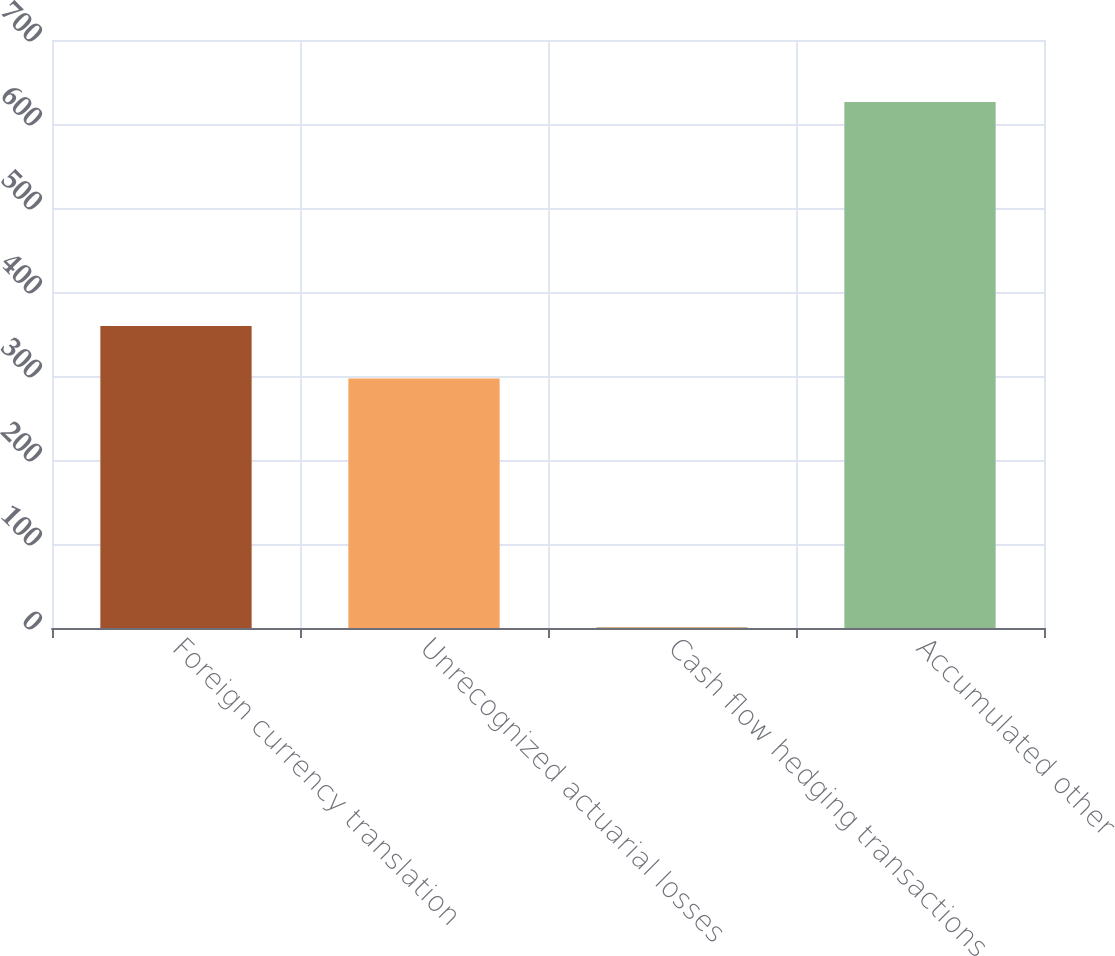<chart> <loc_0><loc_0><loc_500><loc_500><bar_chart><fcel>Foreign currency translation<fcel>Unrecognized actuarial losses<fcel>Cash flow hedging transactions<fcel>Accumulated other<nl><fcel>359.61<fcel>297.1<fcel>1.2<fcel>626.3<nl></chart> 